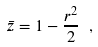<formula> <loc_0><loc_0><loc_500><loc_500>\bar { z } = 1 - \frac { r ^ { 2 } } { 2 } \ ,</formula> 